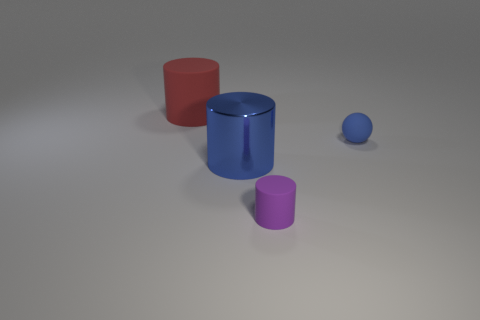Is there another blue matte ball that has the same size as the blue sphere?
Your response must be concise. No. There is a small rubber thing in front of the ball; is its color the same as the ball?
Make the answer very short. No. What number of things are either large blue cylinders or small blue matte things?
Offer a very short reply. 2. Does the blue thing on the left side of the purple cylinder have the same size as the big red matte cylinder?
Offer a very short reply. Yes. What size is the matte object that is both behind the tiny purple cylinder and to the left of the small ball?
Offer a terse response. Large. How many other objects are there of the same shape as the small blue rubber thing?
Make the answer very short. 0. How many other objects are there of the same material as the blue cylinder?
Offer a terse response. 0. There is a purple matte object that is the same shape as the big red object; what is its size?
Provide a succinct answer. Small. Is the color of the large rubber cylinder the same as the tiny sphere?
Provide a short and direct response. No. What color is the object that is right of the blue cylinder and behind the big blue cylinder?
Provide a short and direct response. Blue. 